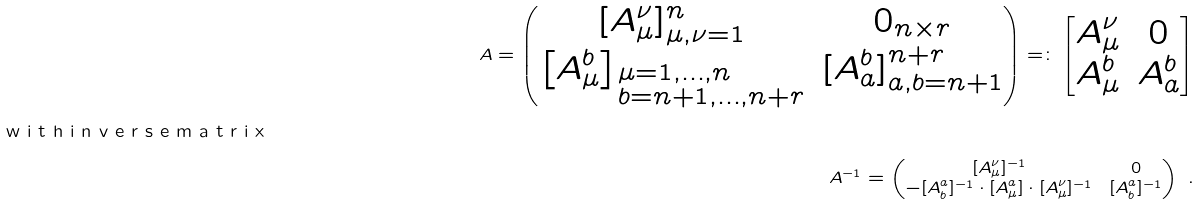Convert formula to latex. <formula><loc_0><loc_0><loc_500><loc_500>A = \begin{pmatrix} [ A _ { \mu } ^ { \nu } ] _ { \mu , \nu = 1 } ^ { n } & 0 _ { n \times r } \\ \left [ A _ { \mu } ^ { b } \right ] _ { \begin{subarray} { l } \mu = 1 , \dots , n \\ b = n + 1 , \dots , n + r \end{subarray} } & [ A _ { a } ^ { b } ] _ { a , b = n + 1 } ^ { n + r } \end{pmatrix} = \colon \begin{bmatrix} A _ { \mu } ^ { \nu } & 0 \\ A _ { \mu } ^ { b } & A _ { a } ^ { b } \end{bmatrix} \\ \intertext { w i t h i n v e r s e m a t r i x } A ^ { - 1 } = \begin{pmatrix} [ A _ { \mu } ^ { \nu } ] ^ { - 1 } & 0 \\ - [ A _ { b } ^ { a } ] ^ { - 1 } \cdot [ A _ { \mu } ^ { a } ] \cdot [ A _ { \mu } ^ { \nu } ] ^ { - 1 } & [ A _ { b } ^ { a } ] ^ { - 1 } \end{pmatrix} \ .</formula> 